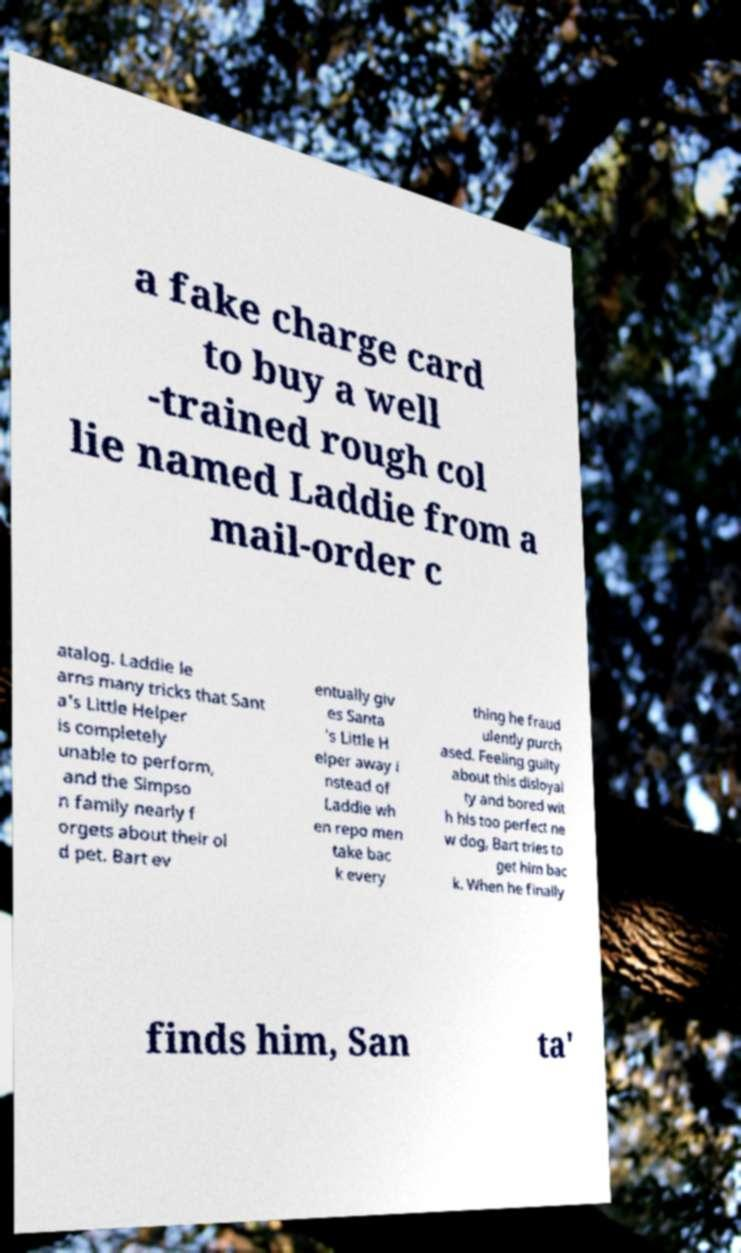I need the written content from this picture converted into text. Can you do that? a fake charge card to buy a well -trained rough col lie named Laddie from a mail-order c atalog. Laddie le arns many tricks that Sant a's Little Helper is completely unable to perform, and the Simpso n family nearly f orgets about their ol d pet. Bart ev entually giv es Santa 's Little H elper away i nstead of Laddie wh en repo men take bac k every thing he fraud ulently purch ased. Feeling guilty about this disloyal ty and bored wit h his too perfect ne w dog, Bart tries to get him bac k. When he finally finds him, San ta' 